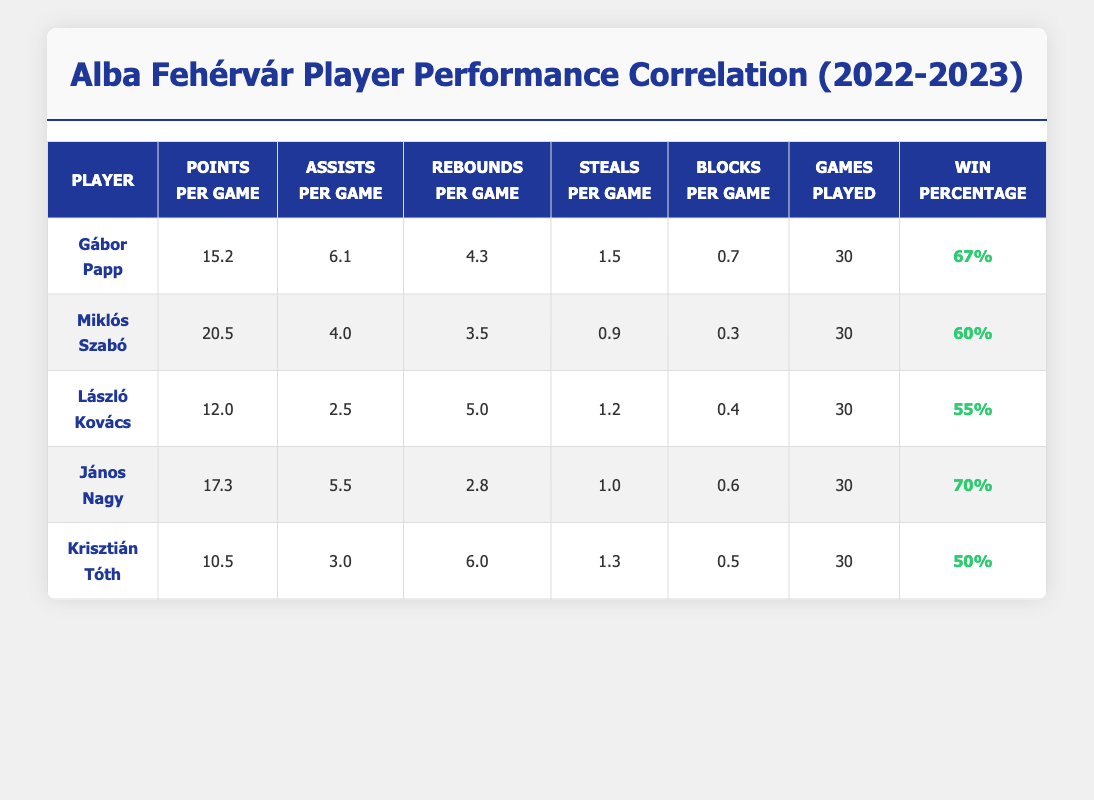What is the highest points per game among the players? By looking at the "Points per Game" column, Miklós Szabó has the highest value at 20.5.
Answer: 20.5 What player has the most assists per game? In the "Assists per Game" column, Gábor Papp has the highest value at 6.1.
Answer: Gábor Papp What is the win percentage of János Nagy? Directly from the "Win Percentage" column, János Nagy has a win percentage of 70%.
Answer: 70% Which player has the lowest rebounds per game? In the "Rebounds per Game" column, János Nagy has the lowest value at 2.8.
Answer: János Nagy What is the average points per game of all players? The total points per game are calculated as (15.2 + 20.5 + 12.0 + 17.3 + 10.5) = 75.5. Dividing by 5 gives an average of 15.1.
Answer: 15.1 Is Krisztián Tóth’s win percentage higher than László Kovács’s? Krisztián Tóth has a win percentage of 50% and László Kovács has 55%. Since 50% is not higher than 55%, the answer is no.
Answer: No How many assists does Miklós Szabó and János Nagy have combined? Adding their assists gives 4.0 (Miklós Szabó) + 5.5 (János Nagy) = 9.5 assists total.
Answer: 9.5 Which player recorded 1.2 steals per game? Looking at the "Steals per Game" column, László Kovács recorded 1.2 steals per game.
Answer: László Kovács What is the difference in win percentage between the highest and lowest players? The highest win percentage is 70% (János Nagy) and the lowest is 50% (Krisztián Tóth). The difference is 70% - 50% = 20%.
Answer: 20% 